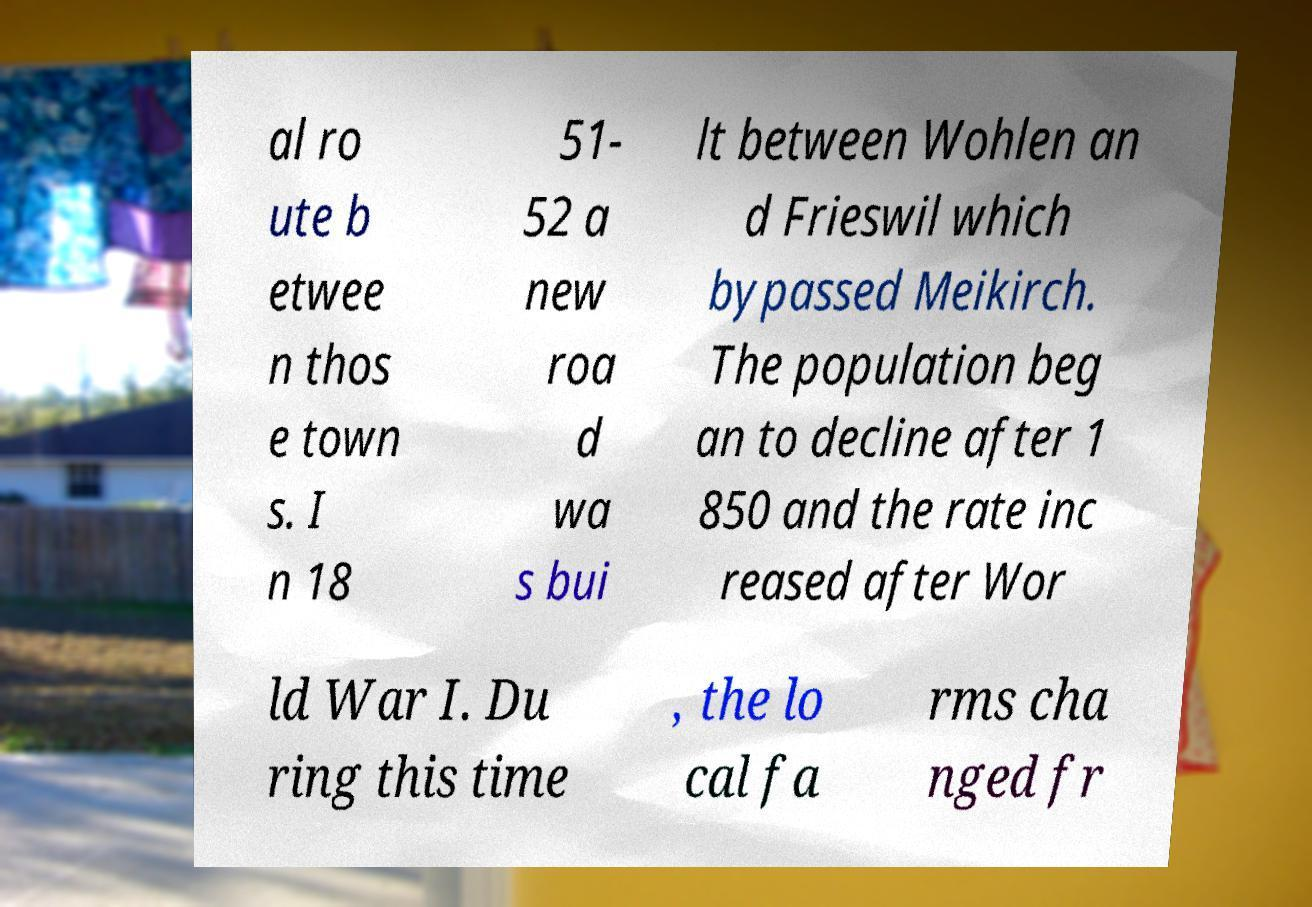Please identify and transcribe the text found in this image. al ro ute b etwee n thos e town s. I n 18 51- 52 a new roa d wa s bui lt between Wohlen an d Frieswil which bypassed Meikirch. The population beg an to decline after 1 850 and the rate inc reased after Wor ld War I. Du ring this time , the lo cal fa rms cha nged fr 